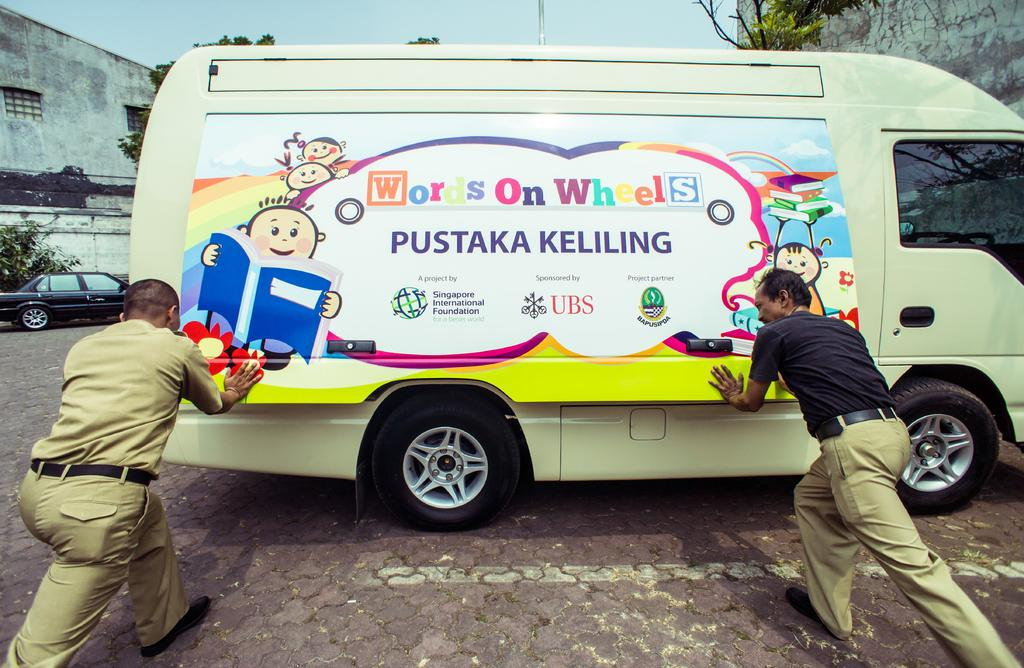How many people are in the image? There are two people in the image. What are the two people doing in the image? The two people are closing a door of a vehicle. What can be seen at the bottom of the image? There is a path visible at the bottom of the image. What structures are visible in the background of the image? There is a house, walls, trees, a plant, a car, and a pole visible in the background of the image. What part of the natural environment is visible in the image? The sky is visible in the background of the image. What type of alarm is going off in the image? There is no alarm present in the image. Can you see an airplane in the image? No, there is no airplane visible in the image. 